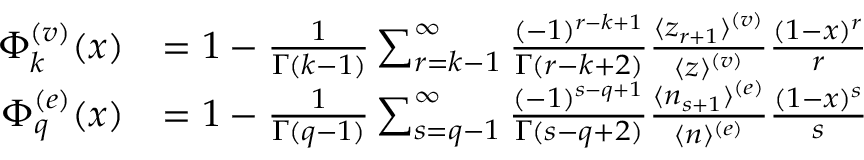Convert formula to latex. <formula><loc_0><loc_0><loc_500><loc_500>\begin{array} { r l } { \Phi _ { k } ^ { ( v ) } ( x ) } & { = 1 - { \frac { 1 } { \Gamma ( k - 1 ) } } \sum _ { r = k - 1 } ^ { \infty } { \frac { ( - 1 ) ^ { r - k + 1 } } { \Gamma ( r - k + 2 ) } } { \frac { \langle z _ { r + 1 } \rangle ^ { ( v ) } } { \langle z \rangle ^ { ( v ) } } } { \frac { ( 1 - x ) ^ { r } } { r } } } \\ { \Phi _ { q } ^ { ( e ) } ( x ) } & { = 1 - { \frac { 1 } { \Gamma ( q - 1 ) } } \sum _ { s = q - 1 } ^ { \infty } { \frac { ( - 1 ) ^ { s - q + 1 } } { \Gamma ( s - q + 2 ) } } { \frac { \langle n _ { s + 1 } \rangle ^ { ( e ) } } { \langle n \rangle ^ { ( e ) } } } { \frac { ( 1 - x ) ^ { s } } { s } } } \end{array}</formula> 